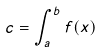Convert formula to latex. <formula><loc_0><loc_0><loc_500><loc_500>c = \int _ { a } ^ { b } f ( x )</formula> 